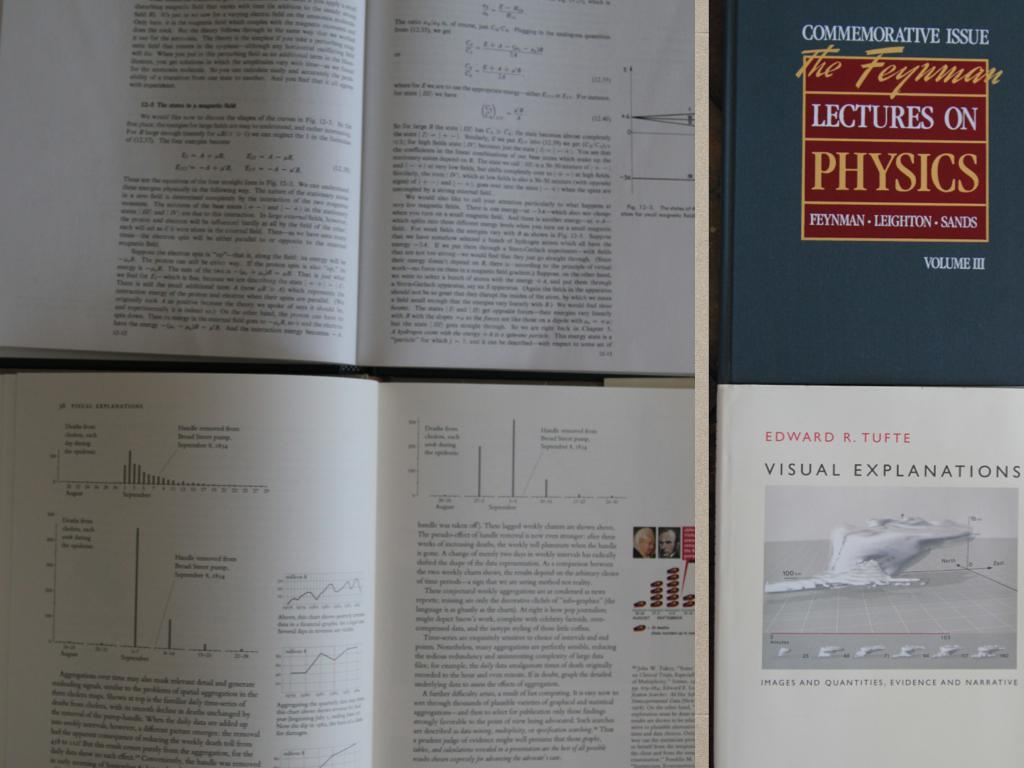<image>
Give a short and clear explanation of the subsequent image. Open books are next to one titled Lectures on Physics. 